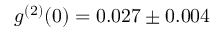<formula> <loc_0><loc_0><loc_500><loc_500>g ^ { ( 2 ) } ( 0 ) = 0 . 0 2 7 \pm 0 . 0 0 4</formula> 